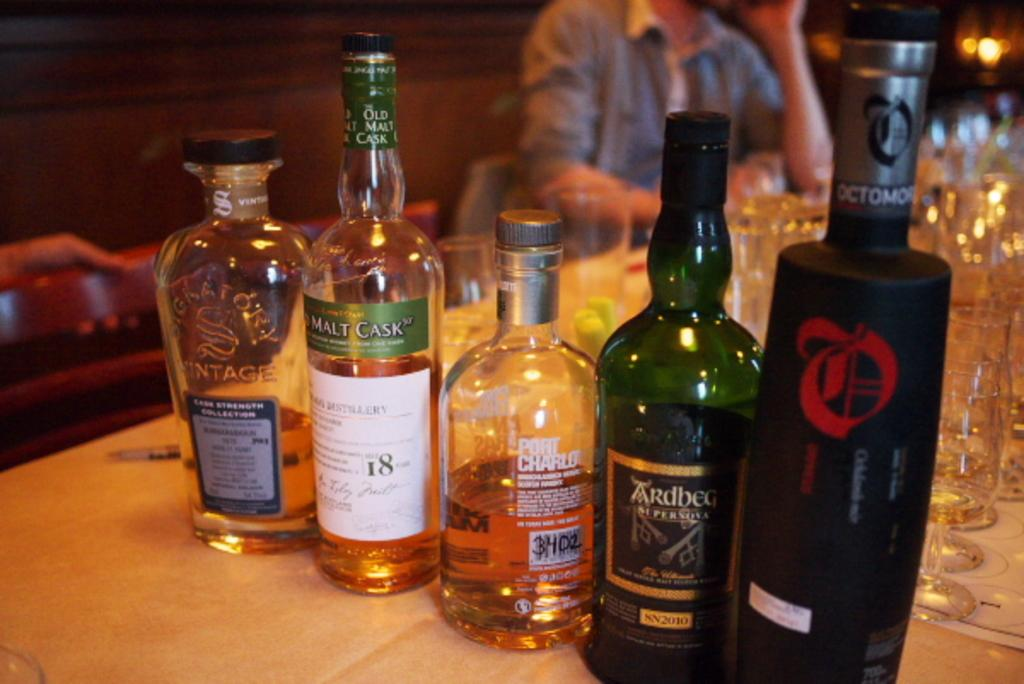What is on the table in the image? There are different bottles of wine on a table. What else can be seen in the image besides the bottles of wine? There are glasses placed behind the table. Is there anyone in the image? Yes, there is a person sitting on a chair. What type of stream can be seen flowing through the room in the image? There is no stream present in the image; it features a table with bottles of wine and glasses, as well as a person sitting on a chair. 